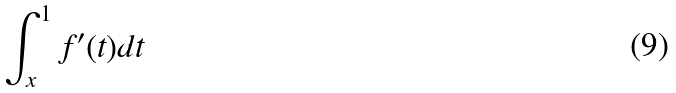<formula> <loc_0><loc_0><loc_500><loc_500>\int _ { x } ^ { 1 } f ^ { \prime } ( t ) d t</formula> 